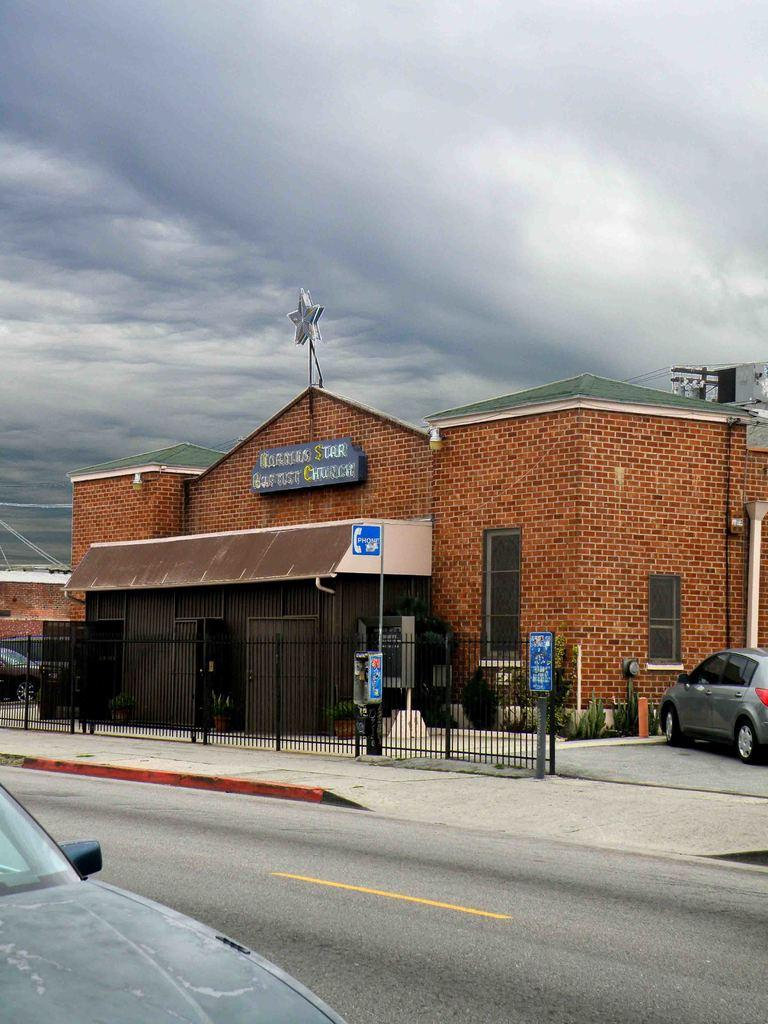What is the main feature of the image? There is a road in the image. How many vehicles can be seen in the image? There are two vehicles in the image. What can be seen in the background of the image? There is a footpath, fencing, and a house in the background of the image. What is visible at the top of the image? The sky is visible at the top of the image, and it appears to be cloudy. What type of eggnog is being served on the footpath in the image? There is no eggnog present in the image; it features a road, vehicles, and background elements such as a footpath, fencing, and a house. What is the net used for in the image? There is no net present in the image. 